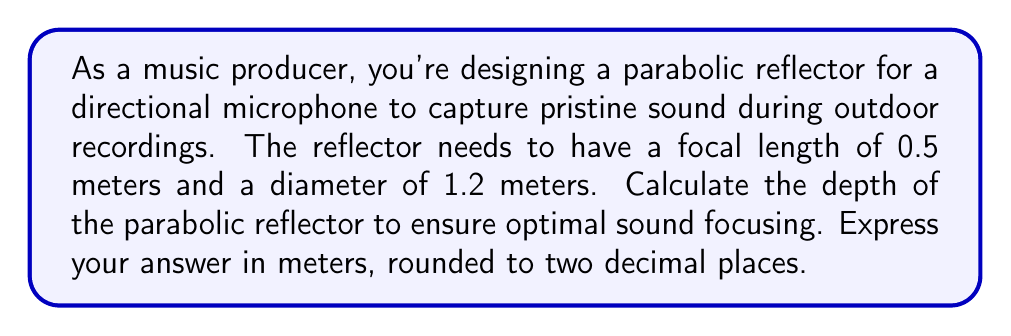Provide a solution to this math problem. To solve this problem, we'll use the equation of a parabola and the given information about the reflector. Let's approach this step-by-step:

1) The general equation of a parabola with vertex at (0,0) is:

   $$y = \frac{1}{4f}x^2$$

   where $f$ is the focal length.

2) We're given that the focal length $f = 0.5$ meters. Substituting this into our equation:

   $$y = \frac{1}{4(0.5)}x^2 = \frac{1}{2}x^2$$

3) The diameter of the reflector is 1.2 meters, so its radius is 0.6 meters. This gives us the x-coordinate of a point on the parabola:

   $$x = 0.6$$

4) To find the depth, we need to calculate the y-coordinate when x = 0.6:

   $$y = \frac{1}{2}(0.6)^2 = \frac{1}{2}(0.36) = 0.18$$

5) This y-value represents the depth of the parabolic reflector.

[asy]
import geometry;

size(200);

real f = 0.5;
real d = 1.2;
real depth = 0.18;

path p = graph(new real(real x) {return x^2/(4*f);}, -d/2, d/2);

draw(p, blue);
draw((-d/2,0)--(d/2,0), arrow=Arrow(TeXHead));
draw((0,0)--(0,depth), arrow=Arrow(TeXHead));

label("0.6 m", (d/2,0), E);
label("0.18 m", (0,depth), E);

dot((0,f));
label("F", (0,f), NE);
[/asy]

The diagram above illustrates the parabolic reflector, with the focal point F and the calculated depth shown.
Answer: The depth of the parabolic reflector is 0.18 meters. 